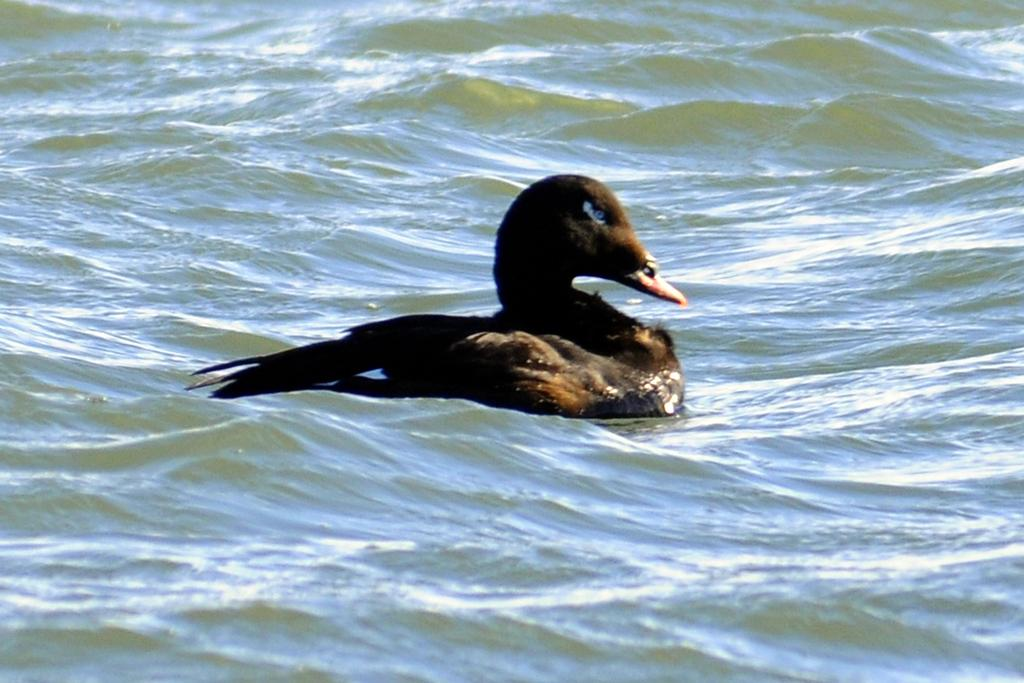What type of animal can be seen in the image? There is a bird in the image. Where is the bird located in the image? The bird is in the water. What is the primary element in which the bird is situated? The bird is situated in water. Can you describe the background of the image? There is water visible in the background of the image. What type of hook can be seen attached to the bird's beak in the image? There is no hook present in the image; it features a bird in the water. 